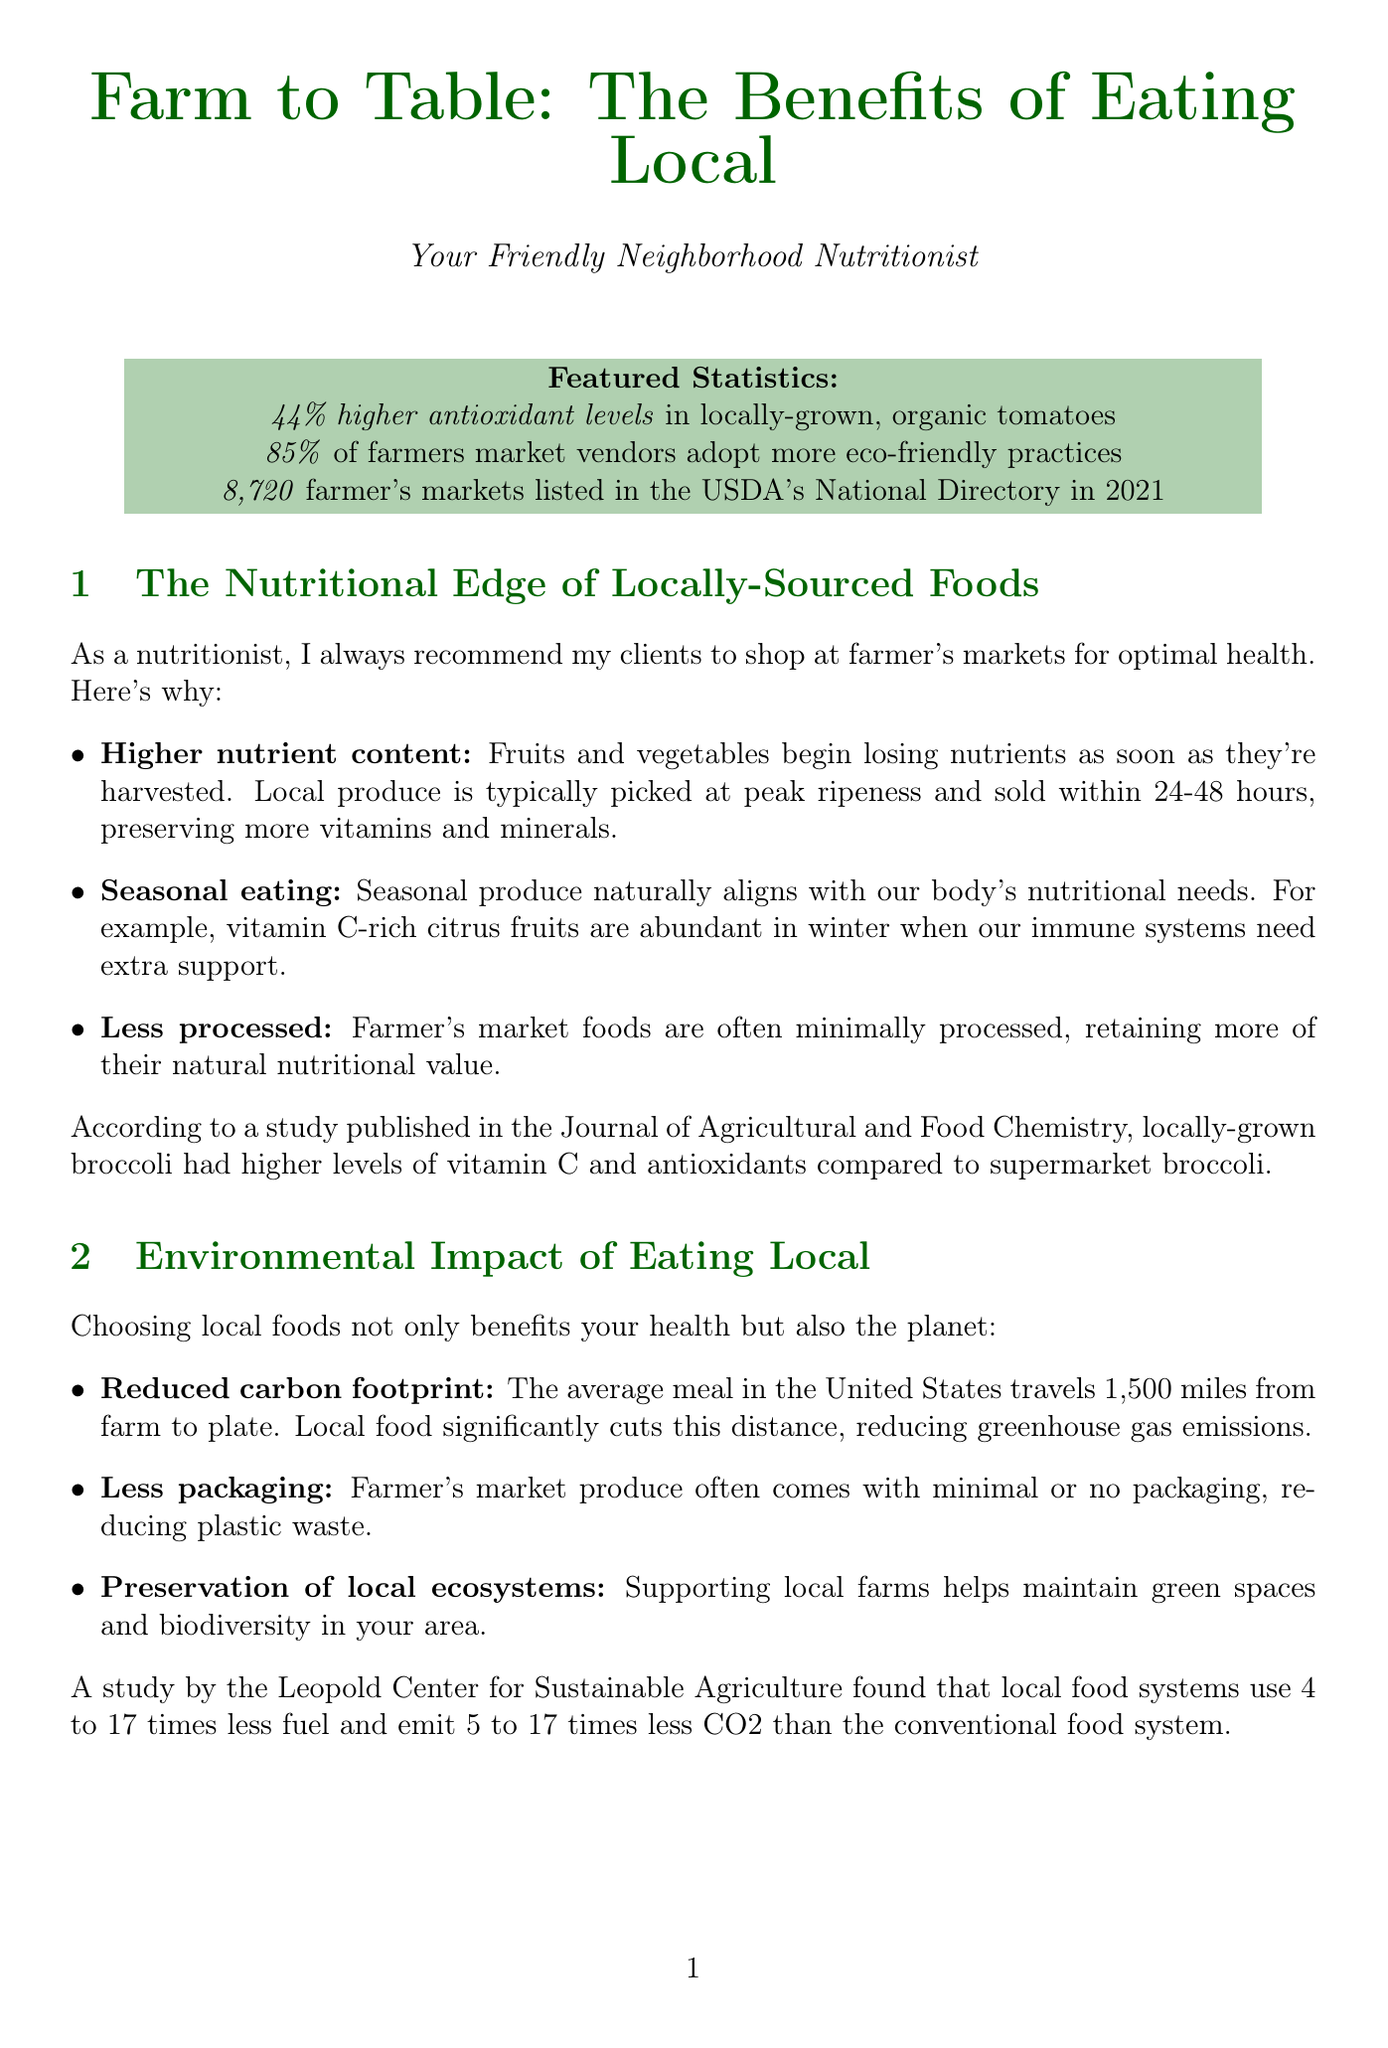What is the percentage of higher antioxidant levels in locally-grown, organic tomatoes? The document states that locally-grown, organic tomatoes have 44% higher antioxidant levels compared to conventionally grown tomatoes.
Answer: 44% How many farmer's markets were listed in the USDA's National Farmer's Market Directory in 2021? According to the document, there were 8,720 farmer's markets listed in the directory in 2021.
Answer: 8,720 What major benefit does shopping at local farmer's markets provide to the economy? The document indicates that for every $100 spent at a local business, $68 remains in the local economy.
Answer: $68 What is a major environmental benefit of choosing local foods according to the document? The document mentions that local food significantly cuts the meal travel distance, reducing greenhouse gas emissions.
Answer: Reduced carbon footprint What is the recommendation for maximizing nutrition and flavor when shopping at farmer's markets? The document suggests planning meals around seasonal produce for maximum nutrition and flavor.
Answer: Seasonal produce What percentage of farmers market vendors adopt more environmentally friendly production practices? According to the document, 85% of farmers market vendors report they adopt more eco-friendly practices.
Answer: 85% Which nutrient is highlighted as being more abundant in winter citrus fruits? The document emphasizes that vitamin C-rich citrus fruits are abundant in winter.
Answer: Vitamin C What type of interaction fosters community connections at farmer's markets? The document states that farmer's markets foster relationships between producers and consumers, creating a sense of community.
Answer: Relationships 